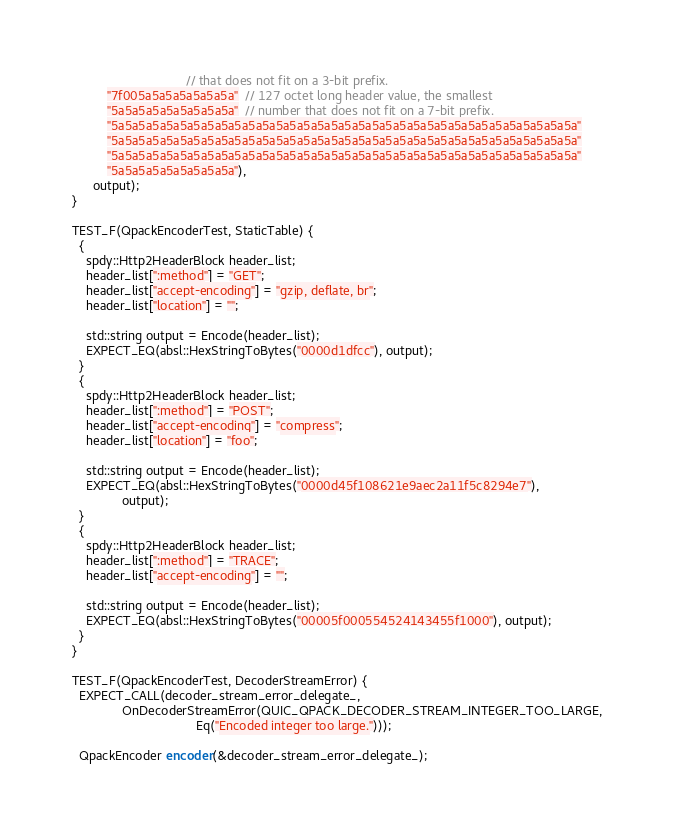<code> <loc_0><loc_0><loc_500><loc_500><_C++_>                                // that does not fit on a 3-bit prefix.
          "7f005a5a5a5a5a5a5a"  // 127 octet long header value, the smallest
          "5a5a5a5a5a5a5a5a5a"  // number that does not fit on a 7-bit prefix.
          "5a5a5a5a5a5a5a5a5a5a5a5a5a5a5a5a5a5a5a5a5a5a5a5a5a5a5a5a5a5a5a5a5a5a"
          "5a5a5a5a5a5a5a5a5a5a5a5a5a5a5a5a5a5a5a5a5a5a5a5a5a5a5a5a5a5a5a5a5a5a"
          "5a5a5a5a5a5a5a5a5a5a5a5a5a5a5a5a5a5a5a5a5a5a5a5a5a5a5a5a5a5a5a5a5a5a"
          "5a5a5a5a5a5a5a5a5a"),
      output);
}

TEST_F(QpackEncoderTest, StaticTable) {
  {
    spdy::Http2HeaderBlock header_list;
    header_list[":method"] = "GET";
    header_list["accept-encoding"] = "gzip, deflate, br";
    header_list["location"] = "";

    std::string output = Encode(header_list);
    EXPECT_EQ(absl::HexStringToBytes("0000d1dfcc"), output);
  }
  {
    spdy::Http2HeaderBlock header_list;
    header_list[":method"] = "POST";
    header_list["accept-encoding"] = "compress";
    header_list["location"] = "foo";

    std::string output = Encode(header_list);
    EXPECT_EQ(absl::HexStringToBytes("0000d45f108621e9aec2a11f5c8294e7"),
              output);
  }
  {
    spdy::Http2HeaderBlock header_list;
    header_list[":method"] = "TRACE";
    header_list["accept-encoding"] = "";

    std::string output = Encode(header_list);
    EXPECT_EQ(absl::HexStringToBytes("00005f000554524143455f1000"), output);
  }
}

TEST_F(QpackEncoderTest, DecoderStreamError) {
  EXPECT_CALL(decoder_stream_error_delegate_,
              OnDecoderStreamError(QUIC_QPACK_DECODER_STREAM_INTEGER_TOO_LARGE,
                                   Eq("Encoded integer too large.")));

  QpackEncoder encoder(&decoder_stream_error_delegate_);</code> 